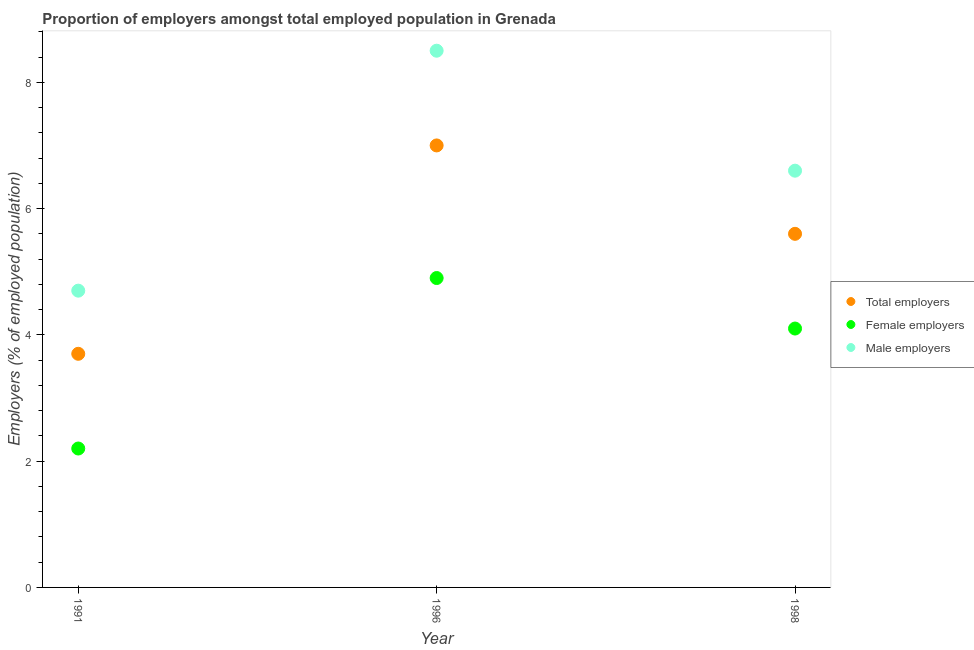How many different coloured dotlines are there?
Make the answer very short. 3. What is the percentage of male employers in 1998?
Provide a succinct answer. 6.6. Across all years, what is the maximum percentage of female employers?
Your answer should be compact. 4.9. Across all years, what is the minimum percentage of total employers?
Your answer should be very brief. 3.7. In which year was the percentage of female employers maximum?
Your response must be concise. 1996. In which year was the percentage of female employers minimum?
Your answer should be compact. 1991. What is the total percentage of male employers in the graph?
Ensure brevity in your answer.  19.8. What is the difference between the percentage of female employers in 1996 and that in 1998?
Give a very brief answer. 0.8. What is the difference between the percentage of female employers in 1998 and the percentage of male employers in 1991?
Provide a succinct answer. -0.6. What is the average percentage of male employers per year?
Ensure brevity in your answer.  6.6. In the year 1996, what is the difference between the percentage of female employers and percentage of male employers?
Provide a short and direct response. -3.6. What is the ratio of the percentage of male employers in 1991 to that in 1996?
Give a very brief answer. 0.55. Is the percentage of male employers in 1991 less than that in 1996?
Keep it short and to the point. Yes. What is the difference between the highest and the second highest percentage of female employers?
Keep it short and to the point. 0.8. What is the difference between the highest and the lowest percentage of male employers?
Keep it short and to the point. 3.8. In how many years, is the percentage of total employers greater than the average percentage of total employers taken over all years?
Offer a terse response. 2. Is it the case that in every year, the sum of the percentage of total employers and percentage of female employers is greater than the percentage of male employers?
Offer a terse response. Yes. Does the percentage of total employers monotonically increase over the years?
Provide a short and direct response. No. How many dotlines are there?
Your answer should be compact. 3. How many years are there in the graph?
Offer a very short reply. 3. Are the values on the major ticks of Y-axis written in scientific E-notation?
Your answer should be very brief. No. Does the graph contain any zero values?
Provide a succinct answer. No. Where does the legend appear in the graph?
Give a very brief answer. Center right. How are the legend labels stacked?
Your answer should be very brief. Vertical. What is the title of the graph?
Ensure brevity in your answer.  Proportion of employers amongst total employed population in Grenada. What is the label or title of the Y-axis?
Keep it short and to the point. Employers (% of employed population). What is the Employers (% of employed population) in Total employers in 1991?
Keep it short and to the point. 3.7. What is the Employers (% of employed population) of Female employers in 1991?
Make the answer very short. 2.2. What is the Employers (% of employed population) of Male employers in 1991?
Your answer should be compact. 4.7. What is the Employers (% of employed population) of Female employers in 1996?
Your answer should be compact. 4.9. What is the Employers (% of employed population) of Total employers in 1998?
Ensure brevity in your answer.  5.6. What is the Employers (% of employed population) of Female employers in 1998?
Make the answer very short. 4.1. What is the Employers (% of employed population) of Male employers in 1998?
Your answer should be compact. 6.6. Across all years, what is the maximum Employers (% of employed population) in Total employers?
Provide a short and direct response. 7. Across all years, what is the maximum Employers (% of employed population) of Female employers?
Your response must be concise. 4.9. Across all years, what is the minimum Employers (% of employed population) of Total employers?
Give a very brief answer. 3.7. Across all years, what is the minimum Employers (% of employed population) of Female employers?
Your answer should be very brief. 2.2. Across all years, what is the minimum Employers (% of employed population) in Male employers?
Your response must be concise. 4.7. What is the total Employers (% of employed population) of Total employers in the graph?
Give a very brief answer. 16.3. What is the total Employers (% of employed population) of Female employers in the graph?
Ensure brevity in your answer.  11.2. What is the total Employers (% of employed population) in Male employers in the graph?
Give a very brief answer. 19.8. What is the difference between the Employers (% of employed population) of Total employers in 1991 and that in 1996?
Ensure brevity in your answer.  -3.3. What is the difference between the Employers (% of employed population) of Female employers in 1991 and that in 1996?
Your answer should be very brief. -2.7. What is the difference between the Employers (% of employed population) in Male employers in 1991 and that in 1996?
Your answer should be compact. -3.8. What is the difference between the Employers (% of employed population) of Total employers in 1991 and that in 1998?
Ensure brevity in your answer.  -1.9. What is the difference between the Employers (% of employed population) in Male employers in 1991 and that in 1998?
Your response must be concise. -1.9. What is the difference between the Employers (% of employed population) of Total employers in 1996 and that in 1998?
Your answer should be compact. 1.4. What is the difference between the Employers (% of employed population) in Male employers in 1996 and that in 1998?
Provide a short and direct response. 1.9. What is the difference between the Employers (% of employed population) of Total employers in 1991 and the Employers (% of employed population) of Male employers in 1996?
Your answer should be very brief. -4.8. What is the difference between the Employers (% of employed population) of Female employers in 1991 and the Employers (% of employed population) of Male employers in 1996?
Offer a terse response. -6.3. What is the difference between the Employers (% of employed population) of Total employers in 1991 and the Employers (% of employed population) of Male employers in 1998?
Your answer should be compact. -2.9. What is the difference between the Employers (% of employed population) in Female employers in 1991 and the Employers (% of employed population) in Male employers in 1998?
Give a very brief answer. -4.4. What is the difference between the Employers (% of employed population) in Total employers in 1996 and the Employers (% of employed population) in Male employers in 1998?
Your response must be concise. 0.4. What is the difference between the Employers (% of employed population) of Female employers in 1996 and the Employers (% of employed population) of Male employers in 1998?
Provide a succinct answer. -1.7. What is the average Employers (% of employed population) in Total employers per year?
Make the answer very short. 5.43. What is the average Employers (% of employed population) in Female employers per year?
Keep it short and to the point. 3.73. In the year 1991, what is the difference between the Employers (% of employed population) of Female employers and Employers (% of employed population) of Male employers?
Keep it short and to the point. -2.5. In the year 1996, what is the difference between the Employers (% of employed population) of Female employers and Employers (% of employed population) of Male employers?
Your answer should be compact. -3.6. In the year 1998, what is the difference between the Employers (% of employed population) of Total employers and Employers (% of employed population) of Female employers?
Your answer should be compact. 1.5. What is the ratio of the Employers (% of employed population) of Total employers in 1991 to that in 1996?
Your response must be concise. 0.53. What is the ratio of the Employers (% of employed population) in Female employers in 1991 to that in 1996?
Your response must be concise. 0.45. What is the ratio of the Employers (% of employed population) of Male employers in 1991 to that in 1996?
Your answer should be compact. 0.55. What is the ratio of the Employers (% of employed population) of Total employers in 1991 to that in 1998?
Offer a terse response. 0.66. What is the ratio of the Employers (% of employed population) of Female employers in 1991 to that in 1998?
Offer a very short reply. 0.54. What is the ratio of the Employers (% of employed population) in Male employers in 1991 to that in 1998?
Your answer should be very brief. 0.71. What is the ratio of the Employers (% of employed population) of Female employers in 1996 to that in 1998?
Give a very brief answer. 1.2. What is the ratio of the Employers (% of employed population) of Male employers in 1996 to that in 1998?
Offer a terse response. 1.29. What is the difference between the highest and the second highest Employers (% of employed population) in Female employers?
Give a very brief answer. 0.8. What is the difference between the highest and the lowest Employers (% of employed population) in Male employers?
Offer a terse response. 3.8. 